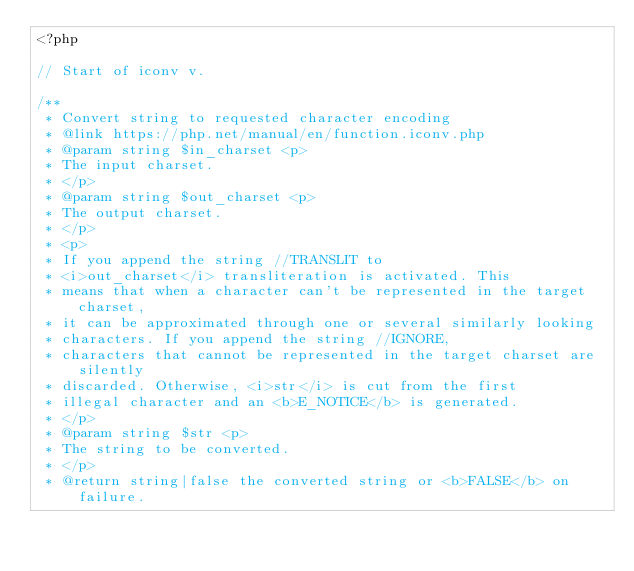Convert code to text. <code><loc_0><loc_0><loc_500><loc_500><_PHP_><?php

// Start of iconv v.

/**
 * Convert string to requested character encoding
 * @link https://php.net/manual/en/function.iconv.php
 * @param string $in_charset <p>
 * The input charset.
 * </p>
 * @param string $out_charset <p>
 * The output charset.
 * </p>
 * <p>
 * If you append the string //TRANSLIT to
 * <i>out_charset</i> transliteration is activated. This
 * means that when a character can't be represented in the target charset,
 * it can be approximated through one or several similarly looking
 * characters. If you append the string //IGNORE,
 * characters that cannot be represented in the target charset are silently
 * discarded. Otherwise, <i>str</i> is cut from the first
 * illegal character and an <b>E_NOTICE</b> is generated.
 * </p>
 * @param string $str <p>
 * The string to be converted.
 * </p>
 * @return string|false the converted string or <b>FALSE</b> on failure.</code> 